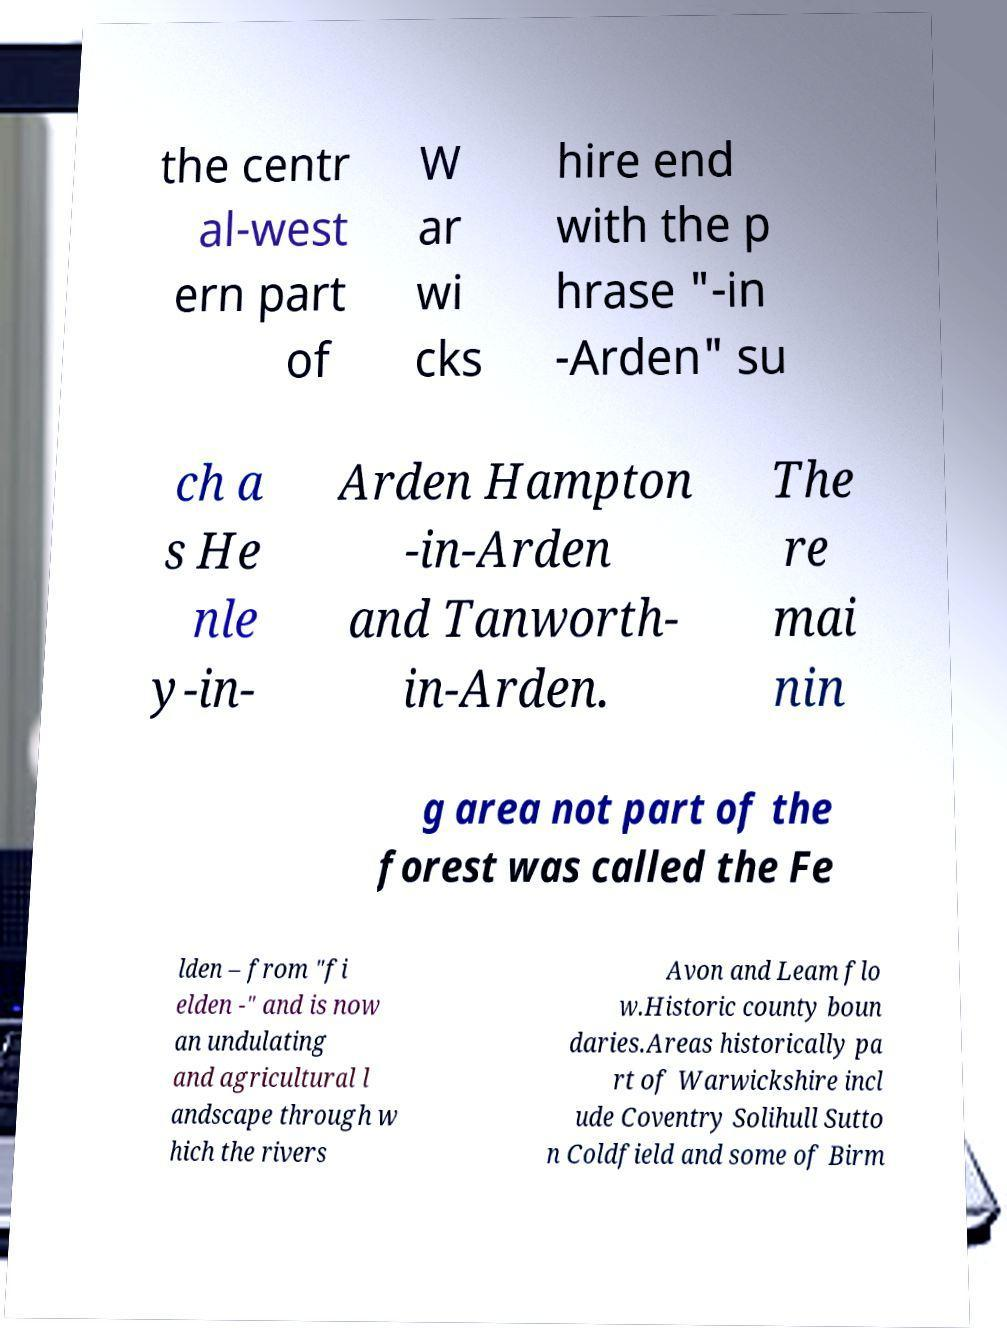Can you accurately transcribe the text from the provided image for me? the centr al-west ern part of W ar wi cks hire end with the p hrase "-in -Arden" su ch a s He nle y-in- Arden Hampton -in-Arden and Tanworth- in-Arden. The re mai nin g area not part of the forest was called the Fe lden – from "fi elden -" and is now an undulating and agricultural l andscape through w hich the rivers Avon and Leam flo w.Historic county boun daries.Areas historically pa rt of Warwickshire incl ude Coventry Solihull Sutto n Coldfield and some of Birm 